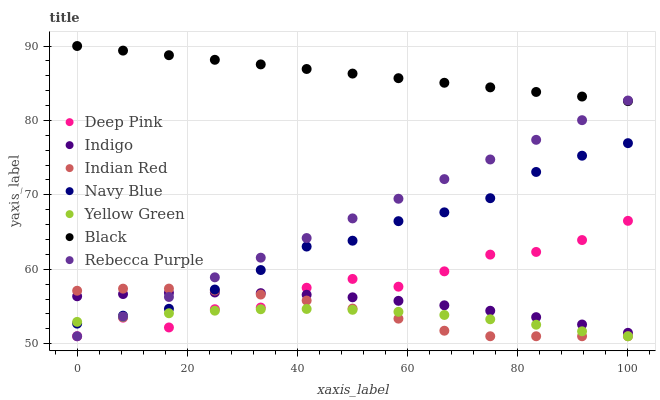Does Yellow Green have the minimum area under the curve?
Answer yes or no. Yes. Does Black have the maximum area under the curve?
Answer yes or no. Yes. Does Indigo have the minimum area under the curve?
Answer yes or no. No. Does Indigo have the maximum area under the curve?
Answer yes or no. No. Is Rebecca Purple the smoothest?
Answer yes or no. Yes. Is Deep Pink the roughest?
Answer yes or no. Yes. Is Indigo the smoothest?
Answer yes or no. No. Is Indigo the roughest?
Answer yes or no. No. Does Deep Pink have the lowest value?
Answer yes or no. Yes. Does Indigo have the lowest value?
Answer yes or no. No. Does Black have the highest value?
Answer yes or no. Yes. Does Indigo have the highest value?
Answer yes or no. No. Is Yellow Green less than Indigo?
Answer yes or no. Yes. Is Black greater than Yellow Green?
Answer yes or no. Yes. Does Black intersect Rebecca Purple?
Answer yes or no. Yes. Is Black less than Rebecca Purple?
Answer yes or no. No. Is Black greater than Rebecca Purple?
Answer yes or no. No. Does Yellow Green intersect Indigo?
Answer yes or no. No. 